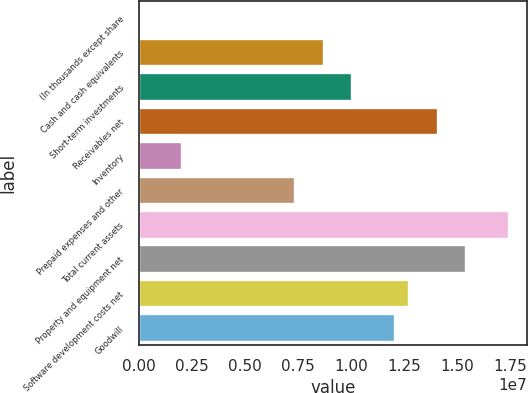<chart> <loc_0><loc_0><loc_500><loc_500><bar_chart><fcel>(In thousands except share<fcel>Cash and cash equivalents<fcel>Short-term investments<fcel>Receivables net<fcel>Inventory<fcel>Prepaid expenses and other<fcel>Total current assets<fcel>Property and equipment net<fcel>Software development costs net<fcel>Goodwill<nl><fcel>2018<fcel>8.72062e+06<fcel>1.00619e+07<fcel>1.40859e+07<fcel>2.014e+06<fcel>7.3793e+06<fcel>1.74392e+07<fcel>1.54272e+07<fcel>1.27446e+07<fcel>1.20739e+07<nl></chart> 